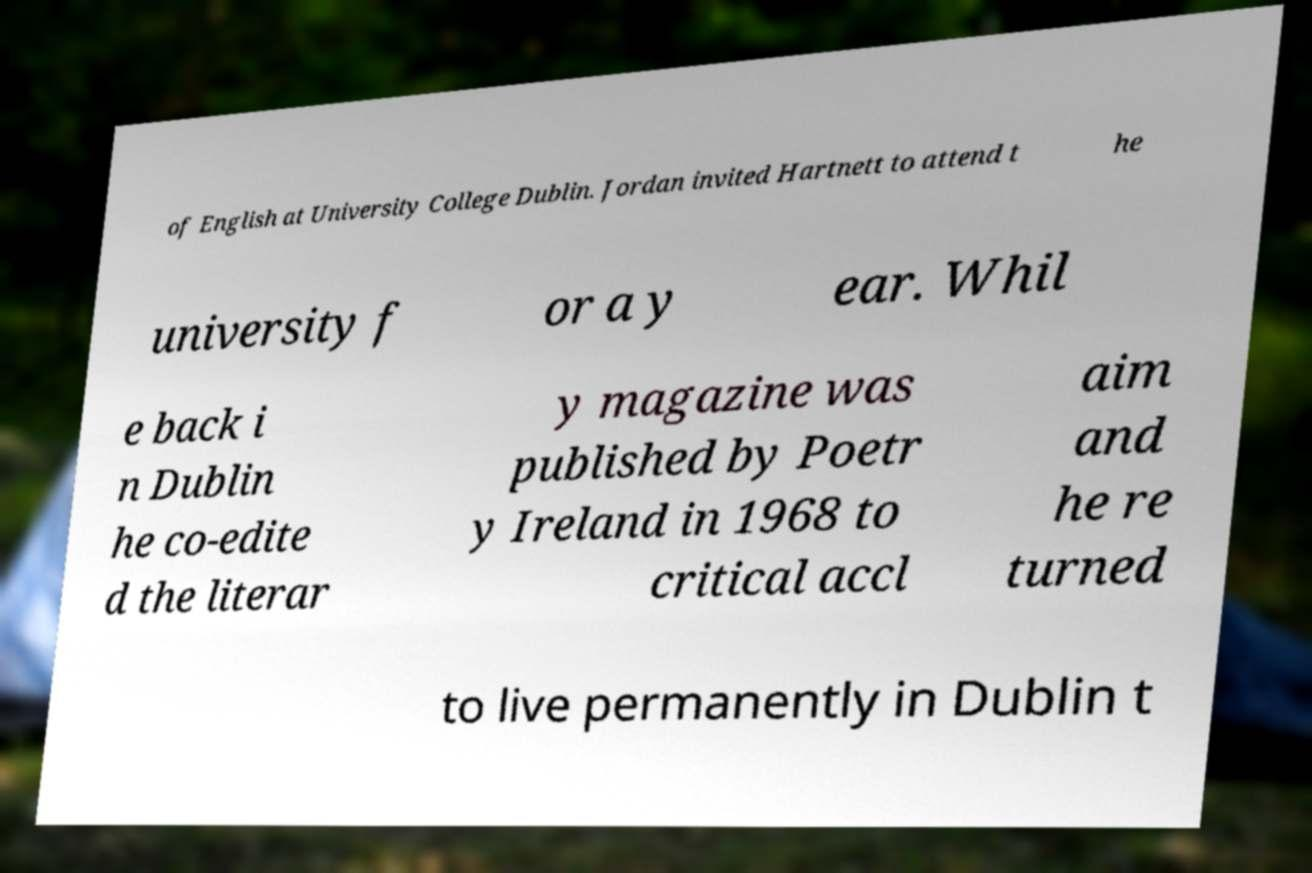Could you assist in decoding the text presented in this image and type it out clearly? of English at University College Dublin. Jordan invited Hartnett to attend t he university f or a y ear. Whil e back i n Dublin he co-edite d the literar y magazine was published by Poetr y Ireland in 1968 to critical accl aim and he re turned to live permanently in Dublin t 